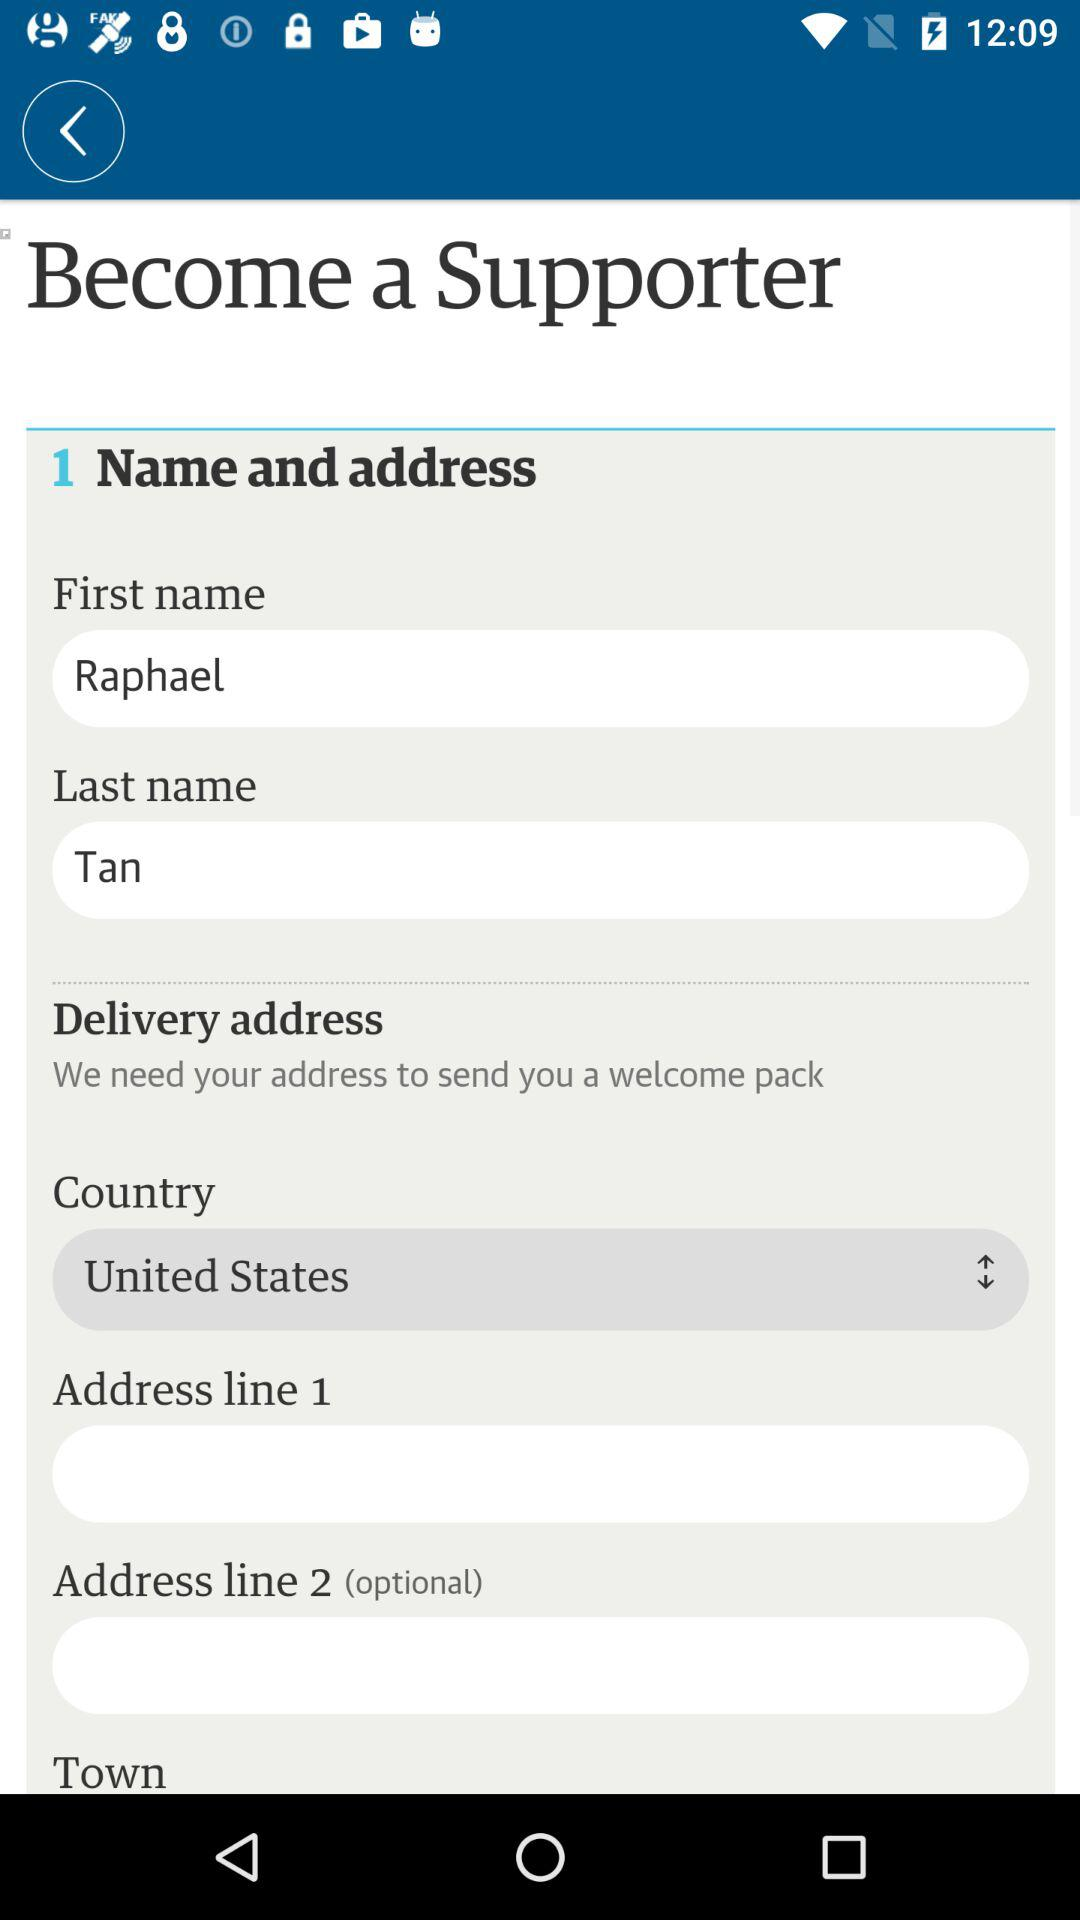How many fields are there in the delivery address section?
Answer the question using a single word or phrase. 4 